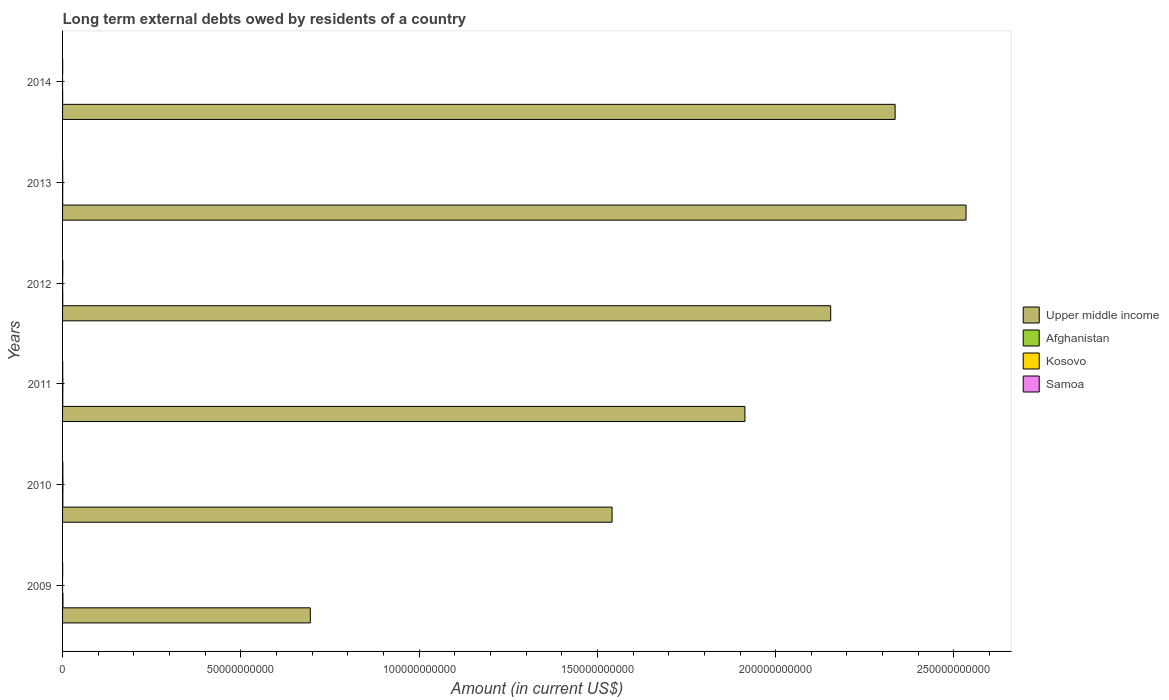How many different coloured bars are there?
Offer a very short reply. 4. How many groups of bars are there?
Ensure brevity in your answer.  6. Are the number of bars per tick equal to the number of legend labels?
Provide a short and direct response. No. How many bars are there on the 5th tick from the bottom?
Your answer should be compact. 4. In how many cases, is the number of bars for a given year not equal to the number of legend labels?
Provide a succinct answer. 2. What is the amount of long-term external debts owed by residents in Afghanistan in 2012?
Provide a short and direct response. 5.12e+07. Across all years, what is the maximum amount of long-term external debts owed by residents in Upper middle income?
Ensure brevity in your answer.  2.53e+11. Across all years, what is the minimum amount of long-term external debts owed by residents in Upper middle income?
Offer a terse response. 6.95e+1. What is the total amount of long-term external debts owed by residents in Samoa in the graph?
Keep it short and to the point. 2.26e+08. What is the difference between the amount of long-term external debts owed by residents in Samoa in 2011 and that in 2014?
Your response must be concise. 1.67e+07. What is the difference between the amount of long-term external debts owed by residents in Afghanistan in 2014 and the amount of long-term external debts owed by residents in Kosovo in 2012?
Provide a short and direct response. 8.03e+06. What is the average amount of long-term external debts owed by residents in Kosovo per year?
Your answer should be compact. 3.78e+07. In the year 2012, what is the difference between the amount of long-term external debts owed by residents in Kosovo and amount of long-term external debts owed by residents in Afghanistan?
Offer a terse response. -3.59e+07. What is the ratio of the amount of long-term external debts owed by residents in Afghanistan in 2009 to that in 2013?
Provide a succinct answer. 3.32. Is the amount of long-term external debts owed by residents in Upper middle income in 2013 less than that in 2014?
Give a very brief answer. No. Is the difference between the amount of long-term external debts owed by residents in Kosovo in 2010 and 2011 greater than the difference between the amount of long-term external debts owed by residents in Afghanistan in 2010 and 2011?
Provide a short and direct response. Yes. What is the difference between the highest and the second highest amount of long-term external debts owed by residents in Samoa?
Give a very brief answer. 1.59e+07. What is the difference between the highest and the lowest amount of long-term external debts owed by residents in Samoa?
Give a very brief answer. 5.53e+07. Is it the case that in every year, the sum of the amount of long-term external debts owed by residents in Kosovo and amount of long-term external debts owed by residents in Samoa is greater than the amount of long-term external debts owed by residents in Afghanistan?
Make the answer very short. No. How many bars are there?
Keep it short and to the point. 22. How many years are there in the graph?
Your answer should be very brief. 6. Does the graph contain any zero values?
Your answer should be very brief. Yes. How are the legend labels stacked?
Ensure brevity in your answer.  Vertical. What is the title of the graph?
Keep it short and to the point. Long term external debts owed by residents of a country. Does "Euro area" appear as one of the legend labels in the graph?
Give a very brief answer. No. What is the Amount (in current US$) in Upper middle income in 2009?
Offer a terse response. 6.95e+1. What is the Amount (in current US$) of Afghanistan in 2009?
Offer a terse response. 1.06e+08. What is the Amount (in current US$) of Kosovo in 2009?
Provide a short and direct response. 0. What is the Amount (in current US$) of Samoa in 2009?
Your answer should be very brief. 1.92e+07. What is the Amount (in current US$) in Upper middle income in 2010?
Your answer should be compact. 1.54e+11. What is the Amount (in current US$) in Afghanistan in 2010?
Your answer should be compact. 7.50e+07. What is the Amount (in current US$) in Kosovo in 2010?
Your response must be concise. 9.39e+07. What is the Amount (in current US$) of Samoa in 2010?
Provide a short and direct response. 7.16e+07. What is the Amount (in current US$) in Upper middle income in 2011?
Ensure brevity in your answer.  1.91e+11. What is the Amount (in current US$) in Afghanistan in 2011?
Provide a succinct answer. 6.14e+07. What is the Amount (in current US$) in Kosovo in 2011?
Offer a very short reply. 7.35e+07. What is the Amount (in current US$) of Samoa in 2011?
Make the answer very short. 3.98e+07. What is the Amount (in current US$) in Upper middle income in 2012?
Your answer should be compact. 2.15e+11. What is the Amount (in current US$) of Afghanistan in 2012?
Provide a succinct answer. 5.12e+07. What is the Amount (in current US$) in Kosovo in 2012?
Provide a short and direct response. 1.53e+07. What is the Amount (in current US$) of Samoa in 2012?
Your answer should be compact. 5.57e+07. What is the Amount (in current US$) of Upper middle income in 2013?
Provide a succinct answer. 2.53e+11. What is the Amount (in current US$) of Afghanistan in 2013?
Ensure brevity in your answer.  3.18e+07. What is the Amount (in current US$) in Kosovo in 2013?
Provide a short and direct response. 4.40e+07. What is the Amount (in current US$) of Samoa in 2013?
Provide a short and direct response. 1.63e+07. What is the Amount (in current US$) in Upper middle income in 2014?
Make the answer very short. 2.34e+11. What is the Amount (in current US$) of Afghanistan in 2014?
Provide a succinct answer. 2.33e+07. What is the Amount (in current US$) of Samoa in 2014?
Provide a succinct answer. 2.31e+07. Across all years, what is the maximum Amount (in current US$) of Upper middle income?
Your answer should be compact. 2.53e+11. Across all years, what is the maximum Amount (in current US$) of Afghanistan?
Provide a short and direct response. 1.06e+08. Across all years, what is the maximum Amount (in current US$) of Kosovo?
Your response must be concise. 9.39e+07. Across all years, what is the maximum Amount (in current US$) of Samoa?
Your answer should be compact. 7.16e+07. Across all years, what is the minimum Amount (in current US$) of Upper middle income?
Keep it short and to the point. 6.95e+1. Across all years, what is the minimum Amount (in current US$) in Afghanistan?
Offer a terse response. 2.33e+07. Across all years, what is the minimum Amount (in current US$) of Kosovo?
Your answer should be very brief. 0. Across all years, what is the minimum Amount (in current US$) in Samoa?
Make the answer very short. 1.63e+07. What is the total Amount (in current US$) of Upper middle income in the graph?
Give a very brief answer. 1.12e+12. What is the total Amount (in current US$) in Afghanistan in the graph?
Keep it short and to the point. 3.48e+08. What is the total Amount (in current US$) in Kosovo in the graph?
Your answer should be compact. 2.27e+08. What is the total Amount (in current US$) of Samoa in the graph?
Your answer should be very brief. 2.26e+08. What is the difference between the Amount (in current US$) in Upper middle income in 2009 and that in 2010?
Offer a terse response. -8.46e+1. What is the difference between the Amount (in current US$) in Afghanistan in 2009 and that in 2010?
Your answer should be compact. 3.06e+07. What is the difference between the Amount (in current US$) in Samoa in 2009 and that in 2010?
Provide a succinct answer. -5.24e+07. What is the difference between the Amount (in current US$) of Upper middle income in 2009 and that in 2011?
Your response must be concise. -1.22e+11. What is the difference between the Amount (in current US$) of Afghanistan in 2009 and that in 2011?
Make the answer very short. 4.43e+07. What is the difference between the Amount (in current US$) of Samoa in 2009 and that in 2011?
Keep it short and to the point. -2.06e+07. What is the difference between the Amount (in current US$) of Upper middle income in 2009 and that in 2012?
Keep it short and to the point. -1.46e+11. What is the difference between the Amount (in current US$) of Afghanistan in 2009 and that in 2012?
Your response must be concise. 5.45e+07. What is the difference between the Amount (in current US$) of Samoa in 2009 and that in 2012?
Give a very brief answer. -3.65e+07. What is the difference between the Amount (in current US$) of Upper middle income in 2009 and that in 2013?
Provide a short and direct response. -1.84e+11. What is the difference between the Amount (in current US$) of Afghanistan in 2009 and that in 2013?
Provide a succinct answer. 7.38e+07. What is the difference between the Amount (in current US$) in Samoa in 2009 and that in 2013?
Provide a short and direct response. 2.89e+06. What is the difference between the Amount (in current US$) of Upper middle income in 2009 and that in 2014?
Keep it short and to the point. -1.64e+11. What is the difference between the Amount (in current US$) in Afghanistan in 2009 and that in 2014?
Provide a short and direct response. 8.23e+07. What is the difference between the Amount (in current US$) of Samoa in 2009 and that in 2014?
Your answer should be very brief. -3.94e+06. What is the difference between the Amount (in current US$) of Upper middle income in 2010 and that in 2011?
Ensure brevity in your answer.  -3.73e+1. What is the difference between the Amount (in current US$) in Afghanistan in 2010 and that in 2011?
Keep it short and to the point. 1.37e+07. What is the difference between the Amount (in current US$) of Kosovo in 2010 and that in 2011?
Offer a terse response. 2.04e+07. What is the difference between the Amount (in current US$) in Samoa in 2010 and that in 2011?
Offer a terse response. 3.18e+07. What is the difference between the Amount (in current US$) of Upper middle income in 2010 and that in 2012?
Provide a short and direct response. -6.13e+1. What is the difference between the Amount (in current US$) of Afghanistan in 2010 and that in 2012?
Give a very brief answer. 2.39e+07. What is the difference between the Amount (in current US$) of Kosovo in 2010 and that in 2012?
Your answer should be very brief. 7.86e+07. What is the difference between the Amount (in current US$) of Samoa in 2010 and that in 2012?
Ensure brevity in your answer.  1.59e+07. What is the difference between the Amount (in current US$) of Upper middle income in 2010 and that in 2013?
Give a very brief answer. -9.93e+1. What is the difference between the Amount (in current US$) in Afghanistan in 2010 and that in 2013?
Your response must be concise. 4.33e+07. What is the difference between the Amount (in current US$) in Kosovo in 2010 and that in 2013?
Your response must be concise. 5.00e+07. What is the difference between the Amount (in current US$) in Samoa in 2010 and that in 2013?
Your answer should be very brief. 5.53e+07. What is the difference between the Amount (in current US$) in Upper middle income in 2010 and that in 2014?
Make the answer very short. -7.94e+1. What is the difference between the Amount (in current US$) of Afghanistan in 2010 and that in 2014?
Your answer should be compact. 5.17e+07. What is the difference between the Amount (in current US$) in Samoa in 2010 and that in 2014?
Offer a terse response. 4.85e+07. What is the difference between the Amount (in current US$) of Upper middle income in 2011 and that in 2012?
Your response must be concise. -2.41e+1. What is the difference between the Amount (in current US$) of Afghanistan in 2011 and that in 2012?
Ensure brevity in your answer.  1.02e+07. What is the difference between the Amount (in current US$) of Kosovo in 2011 and that in 2012?
Your answer should be compact. 5.82e+07. What is the difference between the Amount (in current US$) of Samoa in 2011 and that in 2012?
Your answer should be very brief. -1.59e+07. What is the difference between the Amount (in current US$) of Upper middle income in 2011 and that in 2013?
Keep it short and to the point. -6.20e+1. What is the difference between the Amount (in current US$) of Afghanistan in 2011 and that in 2013?
Keep it short and to the point. 2.96e+07. What is the difference between the Amount (in current US$) of Kosovo in 2011 and that in 2013?
Give a very brief answer. 2.95e+07. What is the difference between the Amount (in current US$) of Samoa in 2011 and that in 2013?
Keep it short and to the point. 2.35e+07. What is the difference between the Amount (in current US$) in Upper middle income in 2011 and that in 2014?
Make the answer very short. -4.21e+1. What is the difference between the Amount (in current US$) of Afghanistan in 2011 and that in 2014?
Ensure brevity in your answer.  3.80e+07. What is the difference between the Amount (in current US$) of Samoa in 2011 and that in 2014?
Your response must be concise. 1.67e+07. What is the difference between the Amount (in current US$) of Upper middle income in 2012 and that in 2013?
Ensure brevity in your answer.  -3.80e+1. What is the difference between the Amount (in current US$) in Afghanistan in 2012 and that in 2013?
Keep it short and to the point. 1.94e+07. What is the difference between the Amount (in current US$) of Kosovo in 2012 and that in 2013?
Your answer should be compact. -2.87e+07. What is the difference between the Amount (in current US$) of Samoa in 2012 and that in 2013?
Ensure brevity in your answer.  3.94e+07. What is the difference between the Amount (in current US$) of Upper middle income in 2012 and that in 2014?
Offer a terse response. -1.81e+1. What is the difference between the Amount (in current US$) of Afghanistan in 2012 and that in 2014?
Provide a succinct answer. 2.78e+07. What is the difference between the Amount (in current US$) of Samoa in 2012 and that in 2014?
Ensure brevity in your answer.  3.26e+07. What is the difference between the Amount (in current US$) in Upper middle income in 2013 and that in 2014?
Provide a short and direct response. 1.99e+1. What is the difference between the Amount (in current US$) in Afghanistan in 2013 and that in 2014?
Keep it short and to the point. 8.45e+06. What is the difference between the Amount (in current US$) in Samoa in 2013 and that in 2014?
Your response must be concise. -6.82e+06. What is the difference between the Amount (in current US$) in Upper middle income in 2009 and the Amount (in current US$) in Afghanistan in 2010?
Offer a terse response. 6.94e+1. What is the difference between the Amount (in current US$) of Upper middle income in 2009 and the Amount (in current US$) of Kosovo in 2010?
Offer a very short reply. 6.94e+1. What is the difference between the Amount (in current US$) of Upper middle income in 2009 and the Amount (in current US$) of Samoa in 2010?
Your response must be concise. 6.94e+1. What is the difference between the Amount (in current US$) of Afghanistan in 2009 and the Amount (in current US$) of Kosovo in 2010?
Your answer should be very brief. 1.17e+07. What is the difference between the Amount (in current US$) of Afghanistan in 2009 and the Amount (in current US$) of Samoa in 2010?
Provide a short and direct response. 3.40e+07. What is the difference between the Amount (in current US$) of Upper middle income in 2009 and the Amount (in current US$) of Afghanistan in 2011?
Make the answer very short. 6.94e+1. What is the difference between the Amount (in current US$) of Upper middle income in 2009 and the Amount (in current US$) of Kosovo in 2011?
Your answer should be very brief. 6.94e+1. What is the difference between the Amount (in current US$) of Upper middle income in 2009 and the Amount (in current US$) of Samoa in 2011?
Ensure brevity in your answer.  6.94e+1. What is the difference between the Amount (in current US$) in Afghanistan in 2009 and the Amount (in current US$) in Kosovo in 2011?
Provide a short and direct response. 3.22e+07. What is the difference between the Amount (in current US$) of Afghanistan in 2009 and the Amount (in current US$) of Samoa in 2011?
Ensure brevity in your answer.  6.58e+07. What is the difference between the Amount (in current US$) in Upper middle income in 2009 and the Amount (in current US$) in Afghanistan in 2012?
Keep it short and to the point. 6.94e+1. What is the difference between the Amount (in current US$) of Upper middle income in 2009 and the Amount (in current US$) of Kosovo in 2012?
Make the answer very short. 6.95e+1. What is the difference between the Amount (in current US$) in Upper middle income in 2009 and the Amount (in current US$) in Samoa in 2012?
Ensure brevity in your answer.  6.94e+1. What is the difference between the Amount (in current US$) of Afghanistan in 2009 and the Amount (in current US$) of Kosovo in 2012?
Offer a terse response. 9.03e+07. What is the difference between the Amount (in current US$) of Afghanistan in 2009 and the Amount (in current US$) of Samoa in 2012?
Offer a terse response. 4.99e+07. What is the difference between the Amount (in current US$) in Upper middle income in 2009 and the Amount (in current US$) in Afghanistan in 2013?
Your answer should be very brief. 6.95e+1. What is the difference between the Amount (in current US$) of Upper middle income in 2009 and the Amount (in current US$) of Kosovo in 2013?
Give a very brief answer. 6.94e+1. What is the difference between the Amount (in current US$) of Upper middle income in 2009 and the Amount (in current US$) of Samoa in 2013?
Provide a short and direct response. 6.95e+1. What is the difference between the Amount (in current US$) in Afghanistan in 2009 and the Amount (in current US$) in Kosovo in 2013?
Keep it short and to the point. 6.17e+07. What is the difference between the Amount (in current US$) of Afghanistan in 2009 and the Amount (in current US$) of Samoa in 2013?
Give a very brief answer. 8.93e+07. What is the difference between the Amount (in current US$) of Upper middle income in 2009 and the Amount (in current US$) of Afghanistan in 2014?
Ensure brevity in your answer.  6.95e+1. What is the difference between the Amount (in current US$) of Upper middle income in 2009 and the Amount (in current US$) of Samoa in 2014?
Your response must be concise. 6.95e+1. What is the difference between the Amount (in current US$) in Afghanistan in 2009 and the Amount (in current US$) in Samoa in 2014?
Offer a very short reply. 8.25e+07. What is the difference between the Amount (in current US$) in Upper middle income in 2010 and the Amount (in current US$) in Afghanistan in 2011?
Provide a succinct answer. 1.54e+11. What is the difference between the Amount (in current US$) of Upper middle income in 2010 and the Amount (in current US$) of Kosovo in 2011?
Your answer should be very brief. 1.54e+11. What is the difference between the Amount (in current US$) of Upper middle income in 2010 and the Amount (in current US$) of Samoa in 2011?
Offer a very short reply. 1.54e+11. What is the difference between the Amount (in current US$) in Afghanistan in 2010 and the Amount (in current US$) in Kosovo in 2011?
Your answer should be very brief. 1.55e+06. What is the difference between the Amount (in current US$) of Afghanistan in 2010 and the Amount (in current US$) of Samoa in 2011?
Your response must be concise. 3.52e+07. What is the difference between the Amount (in current US$) of Kosovo in 2010 and the Amount (in current US$) of Samoa in 2011?
Make the answer very short. 5.41e+07. What is the difference between the Amount (in current US$) of Upper middle income in 2010 and the Amount (in current US$) of Afghanistan in 2012?
Give a very brief answer. 1.54e+11. What is the difference between the Amount (in current US$) in Upper middle income in 2010 and the Amount (in current US$) in Kosovo in 2012?
Provide a short and direct response. 1.54e+11. What is the difference between the Amount (in current US$) in Upper middle income in 2010 and the Amount (in current US$) in Samoa in 2012?
Your answer should be very brief. 1.54e+11. What is the difference between the Amount (in current US$) of Afghanistan in 2010 and the Amount (in current US$) of Kosovo in 2012?
Offer a very short reply. 5.97e+07. What is the difference between the Amount (in current US$) of Afghanistan in 2010 and the Amount (in current US$) of Samoa in 2012?
Your response must be concise. 1.93e+07. What is the difference between the Amount (in current US$) of Kosovo in 2010 and the Amount (in current US$) of Samoa in 2012?
Give a very brief answer. 3.82e+07. What is the difference between the Amount (in current US$) in Upper middle income in 2010 and the Amount (in current US$) in Afghanistan in 2013?
Ensure brevity in your answer.  1.54e+11. What is the difference between the Amount (in current US$) of Upper middle income in 2010 and the Amount (in current US$) of Kosovo in 2013?
Ensure brevity in your answer.  1.54e+11. What is the difference between the Amount (in current US$) in Upper middle income in 2010 and the Amount (in current US$) in Samoa in 2013?
Give a very brief answer. 1.54e+11. What is the difference between the Amount (in current US$) of Afghanistan in 2010 and the Amount (in current US$) of Kosovo in 2013?
Your answer should be very brief. 3.11e+07. What is the difference between the Amount (in current US$) of Afghanistan in 2010 and the Amount (in current US$) of Samoa in 2013?
Give a very brief answer. 5.87e+07. What is the difference between the Amount (in current US$) in Kosovo in 2010 and the Amount (in current US$) in Samoa in 2013?
Keep it short and to the point. 7.76e+07. What is the difference between the Amount (in current US$) of Upper middle income in 2010 and the Amount (in current US$) of Afghanistan in 2014?
Your answer should be compact. 1.54e+11. What is the difference between the Amount (in current US$) in Upper middle income in 2010 and the Amount (in current US$) in Samoa in 2014?
Your response must be concise. 1.54e+11. What is the difference between the Amount (in current US$) of Afghanistan in 2010 and the Amount (in current US$) of Samoa in 2014?
Give a very brief answer. 5.19e+07. What is the difference between the Amount (in current US$) of Kosovo in 2010 and the Amount (in current US$) of Samoa in 2014?
Make the answer very short. 7.08e+07. What is the difference between the Amount (in current US$) in Upper middle income in 2011 and the Amount (in current US$) in Afghanistan in 2012?
Your answer should be very brief. 1.91e+11. What is the difference between the Amount (in current US$) of Upper middle income in 2011 and the Amount (in current US$) of Kosovo in 2012?
Give a very brief answer. 1.91e+11. What is the difference between the Amount (in current US$) of Upper middle income in 2011 and the Amount (in current US$) of Samoa in 2012?
Your answer should be compact. 1.91e+11. What is the difference between the Amount (in current US$) of Afghanistan in 2011 and the Amount (in current US$) of Kosovo in 2012?
Offer a very short reply. 4.61e+07. What is the difference between the Amount (in current US$) of Afghanistan in 2011 and the Amount (in current US$) of Samoa in 2012?
Provide a short and direct response. 5.68e+06. What is the difference between the Amount (in current US$) of Kosovo in 2011 and the Amount (in current US$) of Samoa in 2012?
Your answer should be very brief. 1.78e+07. What is the difference between the Amount (in current US$) of Upper middle income in 2011 and the Amount (in current US$) of Afghanistan in 2013?
Make the answer very short. 1.91e+11. What is the difference between the Amount (in current US$) in Upper middle income in 2011 and the Amount (in current US$) in Kosovo in 2013?
Provide a succinct answer. 1.91e+11. What is the difference between the Amount (in current US$) of Upper middle income in 2011 and the Amount (in current US$) of Samoa in 2013?
Offer a very short reply. 1.91e+11. What is the difference between the Amount (in current US$) of Afghanistan in 2011 and the Amount (in current US$) of Kosovo in 2013?
Ensure brevity in your answer.  1.74e+07. What is the difference between the Amount (in current US$) of Afghanistan in 2011 and the Amount (in current US$) of Samoa in 2013?
Make the answer very short. 4.51e+07. What is the difference between the Amount (in current US$) of Kosovo in 2011 and the Amount (in current US$) of Samoa in 2013?
Make the answer very short. 5.72e+07. What is the difference between the Amount (in current US$) in Upper middle income in 2011 and the Amount (in current US$) in Afghanistan in 2014?
Your answer should be very brief. 1.91e+11. What is the difference between the Amount (in current US$) in Upper middle income in 2011 and the Amount (in current US$) in Samoa in 2014?
Your answer should be compact. 1.91e+11. What is the difference between the Amount (in current US$) of Afghanistan in 2011 and the Amount (in current US$) of Samoa in 2014?
Offer a very short reply. 3.82e+07. What is the difference between the Amount (in current US$) of Kosovo in 2011 and the Amount (in current US$) of Samoa in 2014?
Make the answer very short. 5.03e+07. What is the difference between the Amount (in current US$) of Upper middle income in 2012 and the Amount (in current US$) of Afghanistan in 2013?
Make the answer very short. 2.15e+11. What is the difference between the Amount (in current US$) in Upper middle income in 2012 and the Amount (in current US$) in Kosovo in 2013?
Provide a succinct answer. 2.15e+11. What is the difference between the Amount (in current US$) in Upper middle income in 2012 and the Amount (in current US$) in Samoa in 2013?
Keep it short and to the point. 2.15e+11. What is the difference between the Amount (in current US$) of Afghanistan in 2012 and the Amount (in current US$) of Kosovo in 2013?
Your response must be concise. 7.20e+06. What is the difference between the Amount (in current US$) of Afghanistan in 2012 and the Amount (in current US$) of Samoa in 2013?
Your answer should be very brief. 3.48e+07. What is the difference between the Amount (in current US$) of Kosovo in 2012 and the Amount (in current US$) of Samoa in 2013?
Your answer should be very brief. -1.01e+06. What is the difference between the Amount (in current US$) of Upper middle income in 2012 and the Amount (in current US$) of Afghanistan in 2014?
Make the answer very short. 2.15e+11. What is the difference between the Amount (in current US$) of Upper middle income in 2012 and the Amount (in current US$) of Samoa in 2014?
Offer a terse response. 2.15e+11. What is the difference between the Amount (in current US$) in Afghanistan in 2012 and the Amount (in current US$) in Samoa in 2014?
Keep it short and to the point. 2.80e+07. What is the difference between the Amount (in current US$) of Kosovo in 2012 and the Amount (in current US$) of Samoa in 2014?
Offer a terse response. -7.84e+06. What is the difference between the Amount (in current US$) in Upper middle income in 2013 and the Amount (in current US$) in Afghanistan in 2014?
Provide a succinct answer. 2.53e+11. What is the difference between the Amount (in current US$) in Upper middle income in 2013 and the Amount (in current US$) in Samoa in 2014?
Provide a succinct answer. 2.53e+11. What is the difference between the Amount (in current US$) of Afghanistan in 2013 and the Amount (in current US$) of Samoa in 2014?
Ensure brevity in your answer.  8.64e+06. What is the difference between the Amount (in current US$) of Kosovo in 2013 and the Amount (in current US$) of Samoa in 2014?
Offer a very short reply. 2.08e+07. What is the average Amount (in current US$) in Upper middle income per year?
Ensure brevity in your answer.  1.86e+11. What is the average Amount (in current US$) of Afghanistan per year?
Your answer should be compact. 5.81e+07. What is the average Amount (in current US$) in Kosovo per year?
Ensure brevity in your answer.  3.78e+07. What is the average Amount (in current US$) of Samoa per year?
Your response must be concise. 3.76e+07. In the year 2009, what is the difference between the Amount (in current US$) of Upper middle income and Amount (in current US$) of Afghanistan?
Your response must be concise. 6.94e+1. In the year 2009, what is the difference between the Amount (in current US$) of Upper middle income and Amount (in current US$) of Samoa?
Ensure brevity in your answer.  6.95e+1. In the year 2009, what is the difference between the Amount (in current US$) of Afghanistan and Amount (in current US$) of Samoa?
Give a very brief answer. 8.64e+07. In the year 2010, what is the difference between the Amount (in current US$) in Upper middle income and Amount (in current US$) in Afghanistan?
Offer a very short reply. 1.54e+11. In the year 2010, what is the difference between the Amount (in current US$) of Upper middle income and Amount (in current US$) of Kosovo?
Ensure brevity in your answer.  1.54e+11. In the year 2010, what is the difference between the Amount (in current US$) of Upper middle income and Amount (in current US$) of Samoa?
Ensure brevity in your answer.  1.54e+11. In the year 2010, what is the difference between the Amount (in current US$) of Afghanistan and Amount (in current US$) of Kosovo?
Provide a succinct answer. -1.89e+07. In the year 2010, what is the difference between the Amount (in current US$) in Afghanistan and Amount (in current US$) in Samoa?
Ensure brevity in your answer.  3.43e+06. In the year 2010, what is the difference between the Amount (in current US$) in Kosovo and Amount (in current US$) in Samoa?
Your answer should be very brief. 2.23e+07. In the year 2011, what is the difference between the Amount (in current US$) of Upper middle income and Amount (in current US$) of Afghanistan?
Offer a very short reply. 1.91e+11. In the year 2011, what is the difference between the Amount (in current US$) in Upper middle income and Amount (in current US$) in Kosovo?
Provide a short and direct response. 1.91e+11. In the year 2011, what is the difference between the Amount (in current US$) in Upper middle income and Amount (in current US$) in Samoa?
Your answer should be very brief. 1.91e+11. In the year 2011, what is the difference between the Amount (in current US$) of Afghanistan and Amount (in current US$) of Kosovo?
Ensure brevity in your answer.  -1.21e+07. In the year 2011, what is the difference between the Amount (in current US$) of Afghanistan and Amount (in current US$) of Samoa?
Your answer should be compact. 2.16e+07. In the year 2011, what is the difference between the Amount (in current US$) in Kosovo and Amount (in current US$) in Samoa?
Make the answer very short. 3.37e+07. In the year 2012, what is the difference between the Amount (in current US$) of Upper middle income and Amount (in current US$) of Afghanistan?
Provide a succinct answer. 2.15e+11. In the year 2012, what is the difference between the Amount (in current US$) of Upper middle income and Amount (in current US$) of Kosovo?
Provide a succinct answer. 2.15e+11. In the year 2012, what is the difference between the Amount (in current US$) in Upper middle income and Amount (in current US$) in Samoa?
Ensure brevity in your answer.  2.15e+11. In the year 2012, what is the difference between the Amount (in current US$) in Afghanistan and Amount (in current US$) in Kosovo?
Your response must be concise. 3.59e+07. In the year 2012, what is the difference between the Amount (in current US$) of Afghanistan and Amount (in current US$) of Samoa?
Ensure brevity in your answer.  -4.54e+06. In the year 2012, what is the difference between the Amount (in current US$) of Kosovo and Amount (in current US$) of Samoa?
Offer a terse response. -4.04e+07. In the year 2013, what is the difference between the Amount (in current US$) in Upper middle income and Amount (in current US$) in Afghanistan?
Your answer should be very brief. 2.53e+11. In the year 2013, what is the difference between the Amount (in current US$) in Upper middle income and Amount (in current US$) in Kosovo?
Ensure brevity in your answer.  2.53e+11. In the year 2013, what is the difference between the Amount (in current US$) of Upper middle income and Amount (in current US$) of Samoa?
Offer a very short reply. 2.53e+11. In the year 2013, what is the difference between the Amount (in current US$) in Afghanistan and Amount (in current US$) in Kosovo?
Provide a succinct answer. -1.22e+07. In the year 2013, what is the difference between the Amount (in current US$) in Afghanistan and Amount (in current US$) in Samoa?
Provide a short and direct response. 1.55e+07. In the year 2013, what is the difference between the Amount (in current US$) in Kosovo and Amount (in current US$) in Samoa?
Keep it short and to the point. 2.76e+07. In the year 2014, what is the difference between the Amount (in current US$) of Upper middle income and Amount (in current US$) of Afghanistan?
Your answer should be very brief. 2.33e+11. In the year 2014, what is the difference between the Amount (in current US$) in Upper middle income and Amount (in current US$) in Samoa?
Make the answer very short. 2.33e+11. In the year 2014, what is the difference between the Amount (in current US$) in Afghanistan and Amount (in current US$) in Samoa?
Provide a short and direct response. 1.95e+05. What is the ratio of the Amount (in current US$) in Upper middle income in 2009 to that in 2010?
Provide a succinct answer. 0.45. What is the ratio of the Amount (in current US$) in Afghanistan in 2009 to that in 2010?
Offer a terse response. 1.41. What is the ratio of the Amount (in current US$) in Samoa in 2009 to that in 2010?
Ensure brevity in your answer.  0.27. What is the ratio of the Amount (in current US$) of Upper middle income in 2009 to that in 2011?
Keep it short and to the point. 0.36. What is the ratio of the Amount (in current US$) of Afghanistan in 2009 to that in 2011?
Keep it short and to the point. 1.72. What is the ratio of the Amount (in current US$) in Samoa in 2009 to that in 2011?
Your answer should be very brief. 0.48. What is the ratio of the Amount (in current US$) of Upper middle income in 2009 to that in 2012?
Ensure brevity in your answer.  0.32. What is the ratio of the Amount (in current US$) in Afghanistan in 2009 to that in 2012?
Offer a very short reply. 2.06. What is the ratio of the Amount (in current US$) in Samoa in 2009 to that in 2012?
Your answer should be very brief. 0.34. What is the ratio of the Amount (in current US$) in Upper middle income in 2009 to that in 2013?
Ensure brevity in your answer.  0.27. What is the ratio of the Amount (in current US$) of Afghanistan in 2009 to that in 2013?
Provide a succinct answer. 3.32. What is the ratio of the Amount (in current US$) in Samoa in 2009 to that in 2013?
Ensure brevity in your answer.  1.18. What is the ratio of the Amount (in current US$) in Upper middle income in 2009 to that in 2014?
Ensure brevity in your answer.  0.3. What is the ratio of the Amount (in current US$) in Afghanistan in 2009 to that in 2014?
Make the answer very short. 4.53. What is the ratio of the Amount (in current US$) of Samoa in 2009 to that in 2014?
Give a very brief answer. 0.83. What is the ratio of the Amount (in current US$) in Upper middle income in 2010 to that in 2011?
Your answer should be compact. 0.81. What is the ratio of the Amount (in current US$) in Afghanistan in 2010 to that in 2011?
Ensure brevity in your answer.  1.22. What is the ratio of the Amount (in current US$) in Kosovo in 2010 to that in 2011?
Offer a very short reply. 1.28. What is the ratio of the Amount (in current US$) of Samoa in 2010 to that in 2011?
Offer a very short reply. 1.8. What is the ratio of the Amount (in current US$) in Upper middle income in 2010 to that in 2012?
Provide a succinct answer. 0.72. What is the ratio of the Amount (in current US$) in Afghanistan in 2010 to that in 2012?
Ensure brevity in your answer.  1.47. What is the ratio of the Amount (in current US$) in Kosovo in 2010 to that in 2012?
Your response must be concise. 6.14. What is the ratio of the Amount (in current US$) of Samoa in 2010 to that in 2012?
Make the answer very short. 1.29. What is the ratio of the Amount (in current US$) of Upper middle income in 2010 to that in 2013?
Offer a terse response. 0.61. What is the ratio of the Amount (in current US$) in Afghanistan in 2010 to that in 2013?
Provide a succinct answer. 2.36. What is the ratio of the Amount (in current US$) in Kosovo in 2010 to that in 2013?
Ensure brevity in your answer.  2.14. What is the ratio of the Amount (in current US$) of Samoa in 2010 to that in 2013?
Your answer should be very brief. 4.39. What is the ratio of the Amount (in current US$) in Upper middle income in 2010 to that in 2014?
Provide a succinct answer. 0.66. What is the ratio of the Amount (in current US$) in Afghanistan in 2010 to that in 2014?
Make the answer very short. 3.22. What is the ratio of the Amount (in current US$) of Samoa in 2010 to that in 2014?
Keep it short and to the point. 3.09. What is the ratio of the Amount (in current US$) of Upper middle income in 2011 to that in 2012?
Ensure brevity in your answer.  0.89. What is the ratio of the Amount (in current US$) in Afghanistan in 2011 to that in 2012?
Your response must be concise. 1.2. What is the ratio of the Amount (in current US$) in Kosovo in 2011 to that in 2012?
Make the answer very short. 4.8. What is the ratio of the Amount (in current US$) in Samoa in 2011 to that in 2012?
Your answer should be very brief. 0.71. What is the ratio of the Amount (in current US$) in Upper middle income in 2011 to that in 2013?
Offer a terse response. 0.76. What is the ratio of the Amount (in current US$) in Afghanistan in 2011 to that in 2013?
Provide a succinct answer. 1.93. What is the ratio of the Amount (in current US$) in Kosovo in 2011 to that in 2013?
Provide a short and direct response. 1.67. What is the ratio of the Amount (in current US$) in Samoa in 2011 to that in 2013?
Your answer should be very brief. 2.44. What is the ratio of the Amount (in current US$) of Upper middle income in 2011 to that in 2014?
Give a very brief answer. 0.82. What is the ratio of the Amount (in current US$) in Afghanistan in 2011 to that in 2014?
Provide a short and direct response. 2.63. What is the ratio of the Amount (in current US$) in Samoa in 2011 to that in 2014?
Your answer should be compact. 1.72. What is the ratio of the Amount (in current US$) of Upper middle income in 2012 to that in 2013?
Provide a succinct answer. 0.85. What is the ratio of the Amount (in current US$) in Afghanistan in 2012 to that in 2013?
Offer a very short reply. 1.61. What is the ratio of the Amount (in current US$) in Kosovo in 2012 to that in 2013?
Ensure brevity in your answer.  0.35. What is the ratio of the Amount (in current US$) in Samoa in 2012 to that in 2013?
Offer a very short reply. 3.41. What is the ratio of the Amount (in current US$) of Upper middle income in 2012 to that in 2014?
Provide a short and direct response. 0.92. What is the ratio of the Amount (in current US$) in Afghanistan in 2012 to that in 2014?
Provide a succinct answer. 2.19. What is the ratio of the Amount (in current US$) in Samoa in 2012 to that in 2014?
Make the answer very short. 2.41. What is the ratio of the Amount (in current US$) of Upper middle income in 2013 to that in 2014?
Provide a succinct answer. 1.09. What is the ratio of the Amount (in current US$) in Afghanistan in 2013 to that in 2014?
Offer a very short reply. 1.36. What is the ratio of the Amount (in current US$) in Samoa in 2013 to that in 2014?
Provide a short and direct response. 0.71. What is the difference between the highest and the second highest Amount (in current US$) in Upper middle income?
Provide a short and direct response. 1.99e+1. What is the difference between the highest and the second highest Amount (in current US$) of Afghanistan?
Offer a terse response. 3.06e+07. What is the difference between the highest and the second highest Amount (in current US$) of Kosovo?
Give a very brief answer. 2.04e+07. What is the difference between the highest and the second highest Amount (in current US$) of Samoa?
Provide a succinct answer. 1.59e+07. What is the difference between the highest and the lowest Amount (in current US$) of Upper middle income?
Keep it short and to the point. 1.84e+11. What is the difference between the highest and the lowest Amount (in current US$) in Afghanistan?
Your response must be concise. 8.23e+07. What is the difference between the highest and the lowest Amount (in current US$) of Kosovo?
Offer a very short reply. 9.39e+07. What is the difference between the highest and the lowest Amount (in current US$) in Samoa?
Your answer should be very brief. 5.53e+07. 